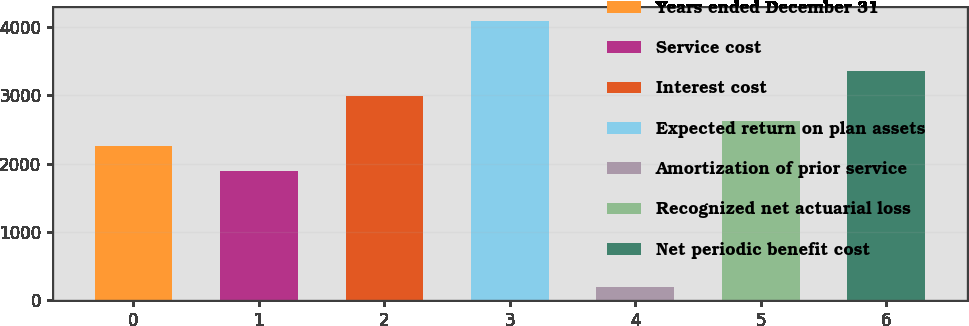Convert chart to OTSL. <chart><loc_0><loc_0><loc_500><loc_500><bar_chart><fcel>Years ended December 31<fcel>Service cost<fcel>Interest cost<fcel>Expected return on plan assets<fcel>Amortization of prior service<fcel>Recognized net actuarial loss<fcel>Net periodic benefit cost<nl><fcel>2253.8<fcel>1886<fcel>2989.4<fcel>4092.8<fcel>196<fcel>2621.6<fcel>3357.2<nl></chart> 